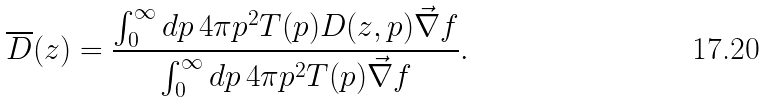<formula> <loc_0><loc_0><loc_500><loc_500>\overline { D } ( z ) = \frac { \int _ { 0 } ^ { \infty } d p \, 4 \pi p ^ { 2 } T ( p ) D ( z , p ) \vec { \nabla } f } { \int _ { 0 } ^ { \infty } d p \, 4 \pi p ^ { 2 } T ( p ) \vec { \nabla } f } .</formula> 